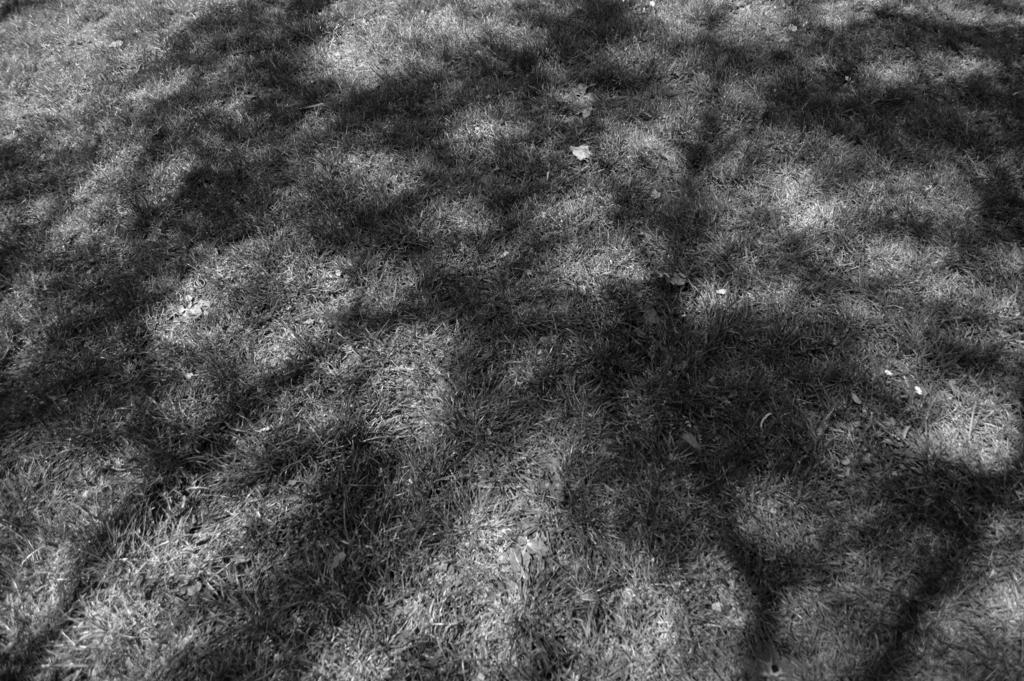Can you describe this image briefly? This is a black and white image. In the image there is grass on the ground. 